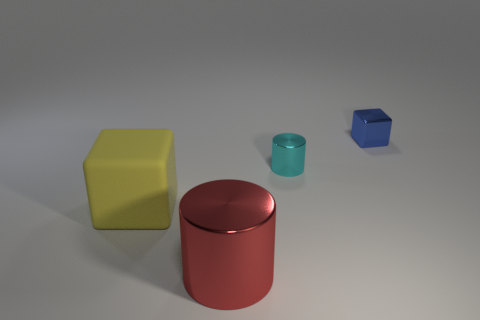How many objects are either big red shiny objects to the left of the metallic block or cylinders left of the small cyan metallic cylinder?
Ensure brevity in your answer.  1. What material is the other object that is the same size as the cyan metal object?
Your answer should be very brief. Metal. The large matte object has what color?
Your answer should be compact. Yellow. What material is the thing that is both to the left of the metallic cube and behind the large block?
Offer a terse response. Metal. There is a small metal object that is to the left of the metallic cube that is to the right of the big yellow matte thing; are there any small cubes that are in front of it?
Offer a terse response. No. Are there any cubes in front of the yellow matte block?
Provide a short and direct response. No. There is a object that is the same size as the cyan metal cylinder; what is its color?
Provide a succinct answer. Blue. Are there fewer large blocks behind the cyan cylinder than big yellow objects in front of the large red object?
Offer a very short reply. No. There is a thing that is to the left of the cylinder on the left side of the cyan shiny cylinder; how many large metallic objects are in front of it?
Your answer should be very brief. 1. There is a red thing that is the same shape as the cyan metallic object; what is its size?
Keep it short and to the point. Large. 